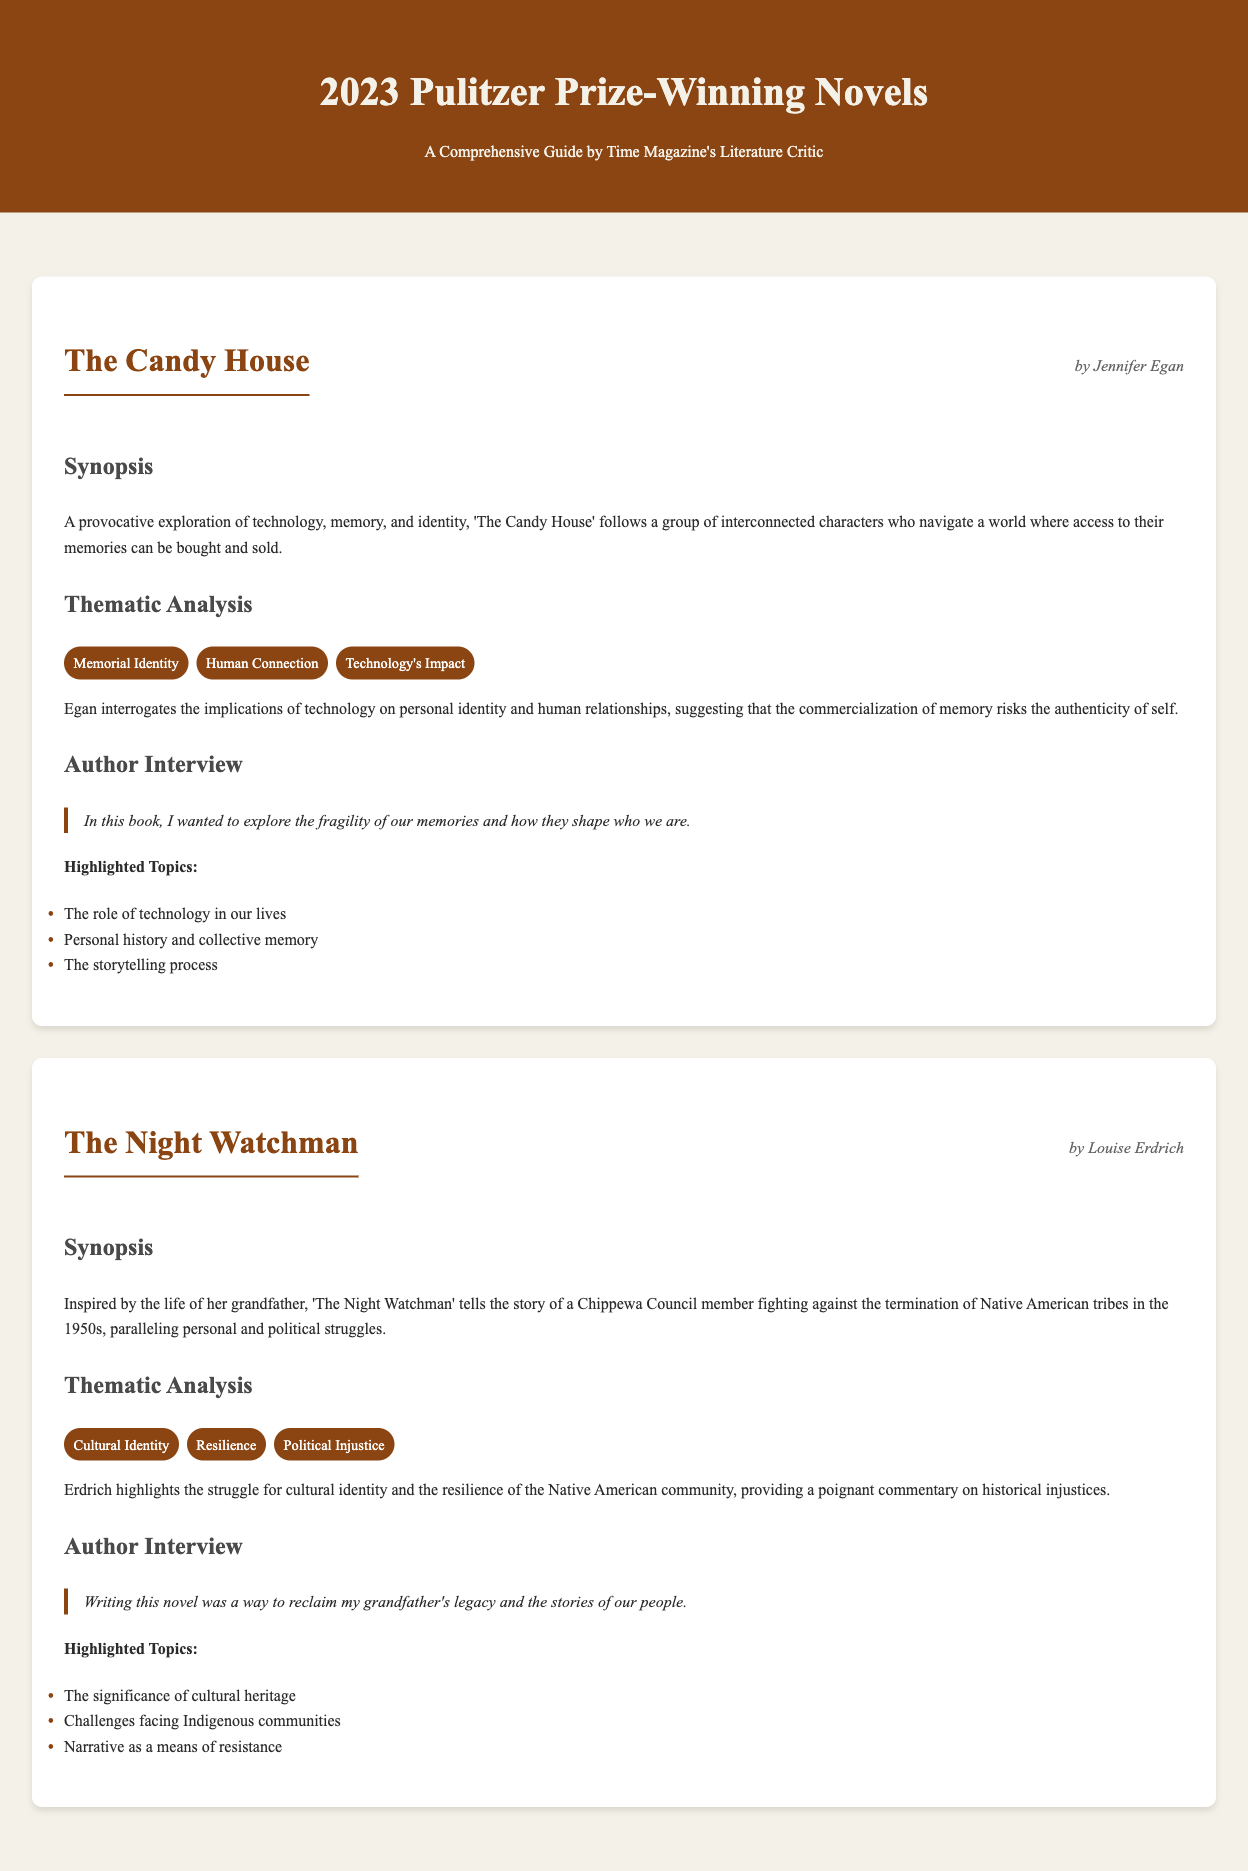What is the title of Jennifer Egan's novel? The document lists the title of the novel by Jennifer Egan.
Answer: The Candy House Who authored 'The Night Watchman'? The document indicates the author of 'The Night Watchman'.
Answer: Louise Erdrich What year are these Pulitzer Prize-winning novels from? The title of the document specifies the year of the Pulitzer Prize-winning novels.
Answer: 2023 What is a theme explored in 'The Candy House'? The document provides a thematic analysis for 'The Candy House', listing several themes.
Answer: Memorial Identity What personal struggle does 'The Night Watchman' parallel? The synopsis of 'The Night Watchman' describes a personal and political struggle.
Answer: Termination of Native American tribes What did Egan want to explore in her novel? The author interview section highlights the author's intention in 'The Candy House'.
Answer: Fragility of our memories How are the two novels categorized in the document structure? The document presents each novel in a distinct format with sections.
Answer: Novel What cultural aspect does 'The Night Watchman' focus on? The thematic analysis of 'The Night Watchman' addresses a specific cultural theme.
Answer: Cultural Identity What was the intent behind writing 'The Night Watchman' according to the author? The author's interview reveals her motivation for writing 'The Night Watchman'.
Answer: Reclaim my grandfather's legacy 